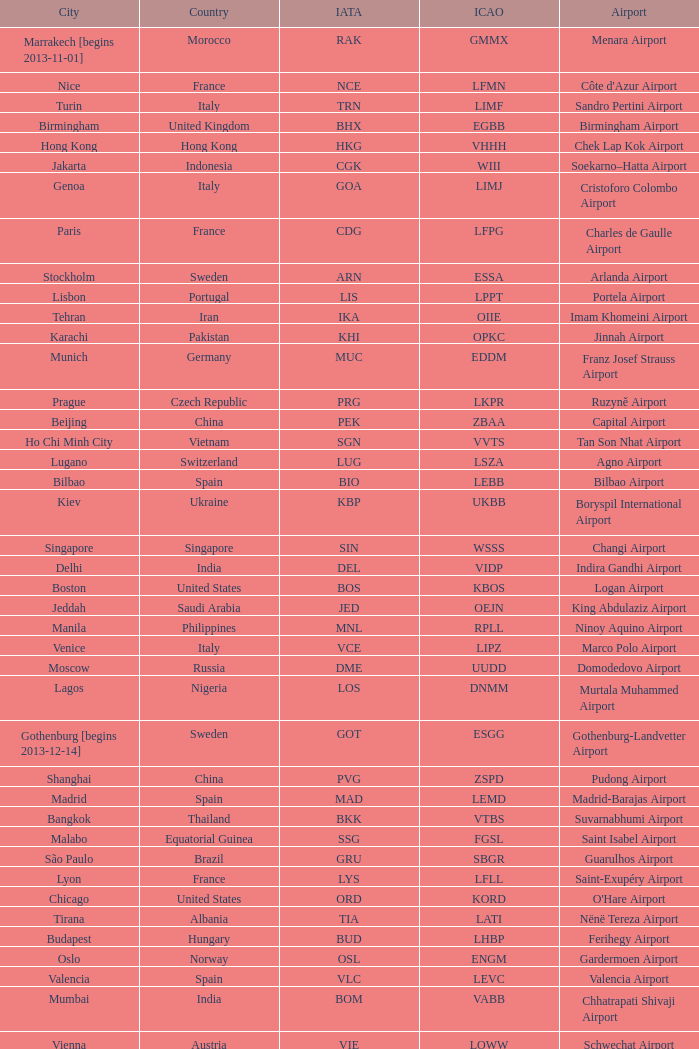Help me parse the entirety of this table. {'header': ['City', 'Country', 'IATA', 'ICAO', 'Airport'], 'rows': [['Marrakech [begins 2013-11-01]', 'Morocco', 'RAK', 'GMMX', 'Menara Airport'], ['Nice', 'France', 'NCE', 'LFMN', "Côte d'Azur Airport"], ['Turin', 'Italy', 'TRN', 'LIMF', 'Sandro Pertini Airport'], ['Birmingham', 'United Kingdom', 'BHX', 'EGBB', 'Birmingham Airport'], ['Hong Kong', 'Hong Kong', 'HKG', 'VHHH', 'Chek Lap Kok Airport'], ['Jakarta', 'Indonesia', 'CGK', 'WIII', 'Soekarno–Hatta Airport'], ['Genoa', 'Italy', 'GOA', 'LIMJ', 'Cristoforo Colombo Airport'], ['Paris', 'France', 'CDG', 'LFPG', 'Charles de Gaulle Airport'], ['Stockholm', 'Sweden', 'ARN', 'ESSA', 'Arlanda Airport'], ['Lisbon', 'Portugal', 'LIS', 'LPPT', 'Portela Airport'], ['Tehran', 'Iran', 'IKA', 'OIIE', 'Imam Khomeini Airport'], ['Karachi', 'Pakistan', 'KHI', 'OPKC', 'Jinnah Airport'], ['Munich', 'Germany', 'MUC', 'EDDM', 'Franz Josef Strauss Airport'], ['Prague', 'Czech Republic', 'PRG', 'LKPR', 'Ruzyně Airport'], ['Beijing', 'China', 'PEK', 'ZBAA', 'Capital Airport'], ['Ho Chi Minh City', 'Vietnam', 'SGN', 'VVTS', 'Tan Son Nhat Airport'], ['Lugano', 'Switzerland', 'LUG', 'LSZA', 'Agno Airport'], ['Bilbao', 'Spain', 'BIO', 'LEBB', 'Bilbao Airport'], ['Kiev', 'Ukraine', 'KBP', 'UKBB', 'Boryspil International Airport'], ['Singapore', 'Singapore', 'SIN', 'WSSS', 'Changi Airport'], ['Delhi', 'India', 'DEL', 'VIDP', 'Indira Gandhi Airport'], ['Boston', 'United States', 'BOS', 'KBOS', 'Logan Airport'], ['Jeddah', 'Saudi Arabia', 'JED', 'OEJN', 'King Abdulaziz Airport'], ['Manila', 'Philippines', 'MNL', 'RPLL', 'Ninoy Aquino Airport'], ['Venice', 'Italy', 'VCE', 'LIPZ', 'Marco Polo Airport'], ['Moscow', 'Russia', 'DME', 'UUDD', 'Domodedovo Airport'], ['Lagos', 'Nigeria', 'LOS', 'DNMM', 'Murtala Muhammed Airport'], ['Gothenburg [begins 2013-12-14]', 'Sweden', 'GOT', 'ESGG', 'Gothenburg-Landvetter Airport'], ['Shanghai', 'China', 'PVG', 'ZSPD', 'Pudong Airport'], ['Madrid', 'Spain', 'MAD', 'LEMD', 'Madrid-Barajas Airport'], ['Bangkok', 'Thailand', 'BKK', 'VTBS', 'Suvarnabhumi Airport'], ['Malabo', 'Equatorial Guinea', 'SSG', 'FGSL', 'Saint Isabel Airport'], ['São Paulo', 'Brazil', 'GRU', 'SBGR', 'Guarulhos Airport'], ['Lyon', 'France', 'LYS', 'LFLL', 'Saint-Exupéry Airport'], ['Chicago', 'United States', 'ORD', 'KORD', "O'Hare Airport"], ['Tirana', 'Albania', 'TIA', 'LATI', 'Nënë Tereza Airport'], ['Budapest', 'Hungary', 'BUD', 'LHBP', 'Ferihegy Airport'], ['Oslo', 'Norway', 'OSL', 'ENGM', 'Gardermoen Airport'], ['Valencia', 'Spain', 'VLC', 'LEVC', 'Valencia Airport'], ['Mumbai', 'India', 'BOM', 'VABB', 'Chhatrapati Shivaji Airport'], ['Vienna', 'Austria', 'VIE', 'LOWW', 'Schwechat Airport'], ['Warsaw', 'Poland', 'WAW', 'EPWA', 'Frederic Chopin Airport'], ['Stuttgart', 'Germany', 'STR', 'EDDS', 'Echterdingen Airport'], ['London', 'United Kingdom', 'LHR', 'EGLL', 'Heathrow Airport'], ['Milan', 'Italy', 'MXP', 'LIMC', 'Malpensa Airport'], ['Tokyo', 'Japan', 'NRT', 'RJAA', 'Narita Airport'], ['Bucharest', 'Romania', 'OTP', 'LROP', 'Otopeni Airport'], ['Helsinki', 'Finland', 'HEL', 'EFHK', 'Vantaa Airport'], ['Zurich', 'Switzerland', 'ZRH', 'LSZH', 'Zurich Airport'], ['Tunis', 'Tunisia', 'TUN', 'DTTA', 'Carthage Airport'], ['Newark', 'United States', 'EWR', 'KEWR', 'Liberty Airport'], ['Malaga', 'Spain', 'AGP', 'LEMG', 'Málaga-Costa del Sol Airport'], ['Washington DC', 'United States', 'IAD', 'KIAD', 'Dulles Airport'], ['Florence', 'Italy', 'FLR', 'LIRQ', 'Peretola Airport'], ['Miami', 'United States', 'MIA', 'KMIA', 'Miami Airport'], ['Dar es Salaam', 'Tanzania', 'DAR', 'HTDA', 'Julius Nyerere Airport'], ['Manchester', 'United Kingdom', 'MAN', 'EGCC', 'Ringway Airport'], ['Barcelona', 'Spain', 'BCN', 'LEBL', 'Barcelona-El Prat Airport'], ['Beirut', 'Lebanon', 'BEY', 'OLBA', 'Rafic Hariri Airport'], ['Luxembourg City', 'Luxembourg', 'LUX', 'ELLX', 'Findel Airport'], ['Caracas', 'Venezuela', 'CCS', 'SVMI', 'Simón Bolívar Airport'], ['Palma de Mallorca', 'Spain', 'PMI', 'LFPA', 'Palma de Mallorca Airport'], ['Seattle', 'United States', 'SEA', 'KSEA', 'Sea-Tac Airport'], ['Riga', 'Latvia', 'RIX', 'EVRA', 'Riga Airport'], ['Montreal', 'Canada', 'YUL', 'CYUL', 'Pierre Elliott Trudeau Airport'], ['Geneva', 'Switzerland', 'GVA', 'LSGG', 'Cointrin Airport'], ['Saint Petersburg', 'Russia', 'LED', 'ULLI', 'Pulkovo Airport'], ['Rio de Janeiro [resumes 2014-7-14]', 'Brazil', 'GIG', 'SBGL', 'Galeão Airport'], ['Rome', 'Italy', 'FCO', 'LIRF', 'Leonardo da Vinci Airport'], ['Skopje', 'Republic of Macedonia', 'SKP', 'LWSK', 'Alexander the Great Airport'], ['Muscat', 'Oman', 'MCT', 'OOMS', 'Seeb Airport'], ['Toronto', 'Canada', 'YYZ', 'CYYZ', 'Pearson Airport'], ['Riyadh', 'Saudi Arabia', 'RUH', 'OERK', 'King Khalid Airport'], ['Tripoli', 'Libya', 'TIP', 'HLLT', 'Tripoli Airport'], ['Dubai', 'United Arab Emirates', 'DXB', 'OMDB', 'Dubai Airport'], ['Atlanta', 'United States', 'ATL', 'KATL', 'Hartsfield–Jackson Airport'], ['Buenos Aires', 'Argentina', 'EZE', 'SAEZ', 'Ministro Pistarini Airport (Ezeiza)'], ['Cairo', 'Egypt', 'CAI', 'HECA', 'Cairo Airport'], ['New York City', 'United States', 'JFK', 'KJFK', 'John F Kennedy Airport'], ['Abu Dhabi', 'United Arab Emirates', 'AUH', 'OMAA', 'Abu Dhabi Airport'], ['Yaounde', 'Cameroon', 'NSI', 'FKYS', 'Yaounde Nsimalen Airport'], ['Accra', 'Ghana', 'ACC', 'DGAA', 'Kotoka Airport'], ['Istanbul', 'Turkey', 'IST', 'LTBA', 'Atatürk Airport'], ['Yerevan', 'Armenia', 'EVN', 'UDYZ', 'Zvartnots Airport'], ['Taipei', 'Taiwan', 'TPE', 'RCTP', 'Taoyuan Airport'], ['Düsseldorf', 'Germany', 'DUS', 'EDDL', 'Lohausen Airport'], ['Minneapolis', 'United States', 'MSP', 'KMSP', 'Minneapolis Airport'], ['Berlin', 'Germany', 'TXL', 'EDDT', 'Tegel Airport'], ['Hamburg', 'Germany', 'HAM', 'EDDH', 'Fuhlsbüttel Airport'], ['Sofia', 'Bulgaria', 'SOF', 'LBSF', 'Vrazhdebna Airport'], ['Santiago', 'Chile', 'SCL', 'SCEL', 'Comodoro Arturo Benitez Airport'], ['Frankfurt', 'Germany', 'FRA', 'EDDF', 'Frankfurt am Main Airport'], ['Brussels', 'Belgium', 'BRU', 'EBBR', 'Brussels Airport'], ['Benghazi', 'Libya', 'BEN', 'HLLB', 'Benina Airport'], ['Los Angeles', 'United States', 'LAX', 'KLAX', 'Los Angeles International Airport'], ['Hannover', 'Germany', 'HAJ', 'EDDV', 'Langenhagen Airport'], ['Nuremberg', 'Germany', 'NUE', 'EDDN', 'Nuremberg Airport'], ['Casablanca', 'Morocco', 'CMN', 'GMMN', 'Mohammed V Airport'], ['Basel Mulhouse Freiburg', 'Switzerland France Germany', 'BSL MLH EAP', 'LFSB', 'Euro Airport'], ['Dublin', 'Ireland', 'DUB', 'EIDW', 'Dublin Airport'], ['Thessaloniki', 'Greece', 'SKG', 'LGTS', 'Macedonia Airport'], ['Sarajevo', 'Bosnia and Herzegovina', 'SJJ', 'LQSA', 'Butmir Airport'], ['London', 'United Kingdom', 'LCY', 'EGLC', 'City Airport'], ['Porto', 'Portugal', 'OPO', 'LPPR', 'Francisco de Sa Carneiro Airport'], ['Belgrade', 'Serbia', 'BEG', 'LYBE', 'Nikola Tesla Airport'], ['Amsterdam', 'Netherlands', 'AMS', 'EHAM', 'Amsterdam Airport Schiphol'], ['Tel Aviv', 'Israel', 'TLV', 'LLBG', 'Ben Gurion Airport'], ['Copenhagen', 'Denmark', 'CPH', 'EKCH', 'Kastrup Airport'], ['Nairobi', 'Kenya', 'NBO', 'HKJK', 'Jomo Kenyatta Airport'], ['Douala', 'Cameroon', 'DLA', 'FKKD', 'Douala Airport'], ['Johannesburg', 'South Africa', 'JNB', 'FAJS', 'OR Tambo Airport'], ['Libreville', 'Gabon', 'LBV', 'FOOL', "Leon M'ba Airport"], ['Athens', 'Greece', 'ATH', 'LGAV', 'Eleftherios Venizelos Airport'], ['London [begins 2013-12-14]', 'United Kingdom', 'LGW', 'EGKK', 'Gatwick Airport'], ['San Francisco', 'United States', 'SFO', 'KSFO', 'San Francisco Airport']]} What is the ICAO of Lohausen airport? EDDL. 